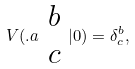Convert formula to latex. <formula><loc_0><loc_0><loc_500><loc_500>V ( . a \begin{array} { c } b \\ c \end{array} | 0 ) = \delta _ { c } ^ { b } ,</formula> 